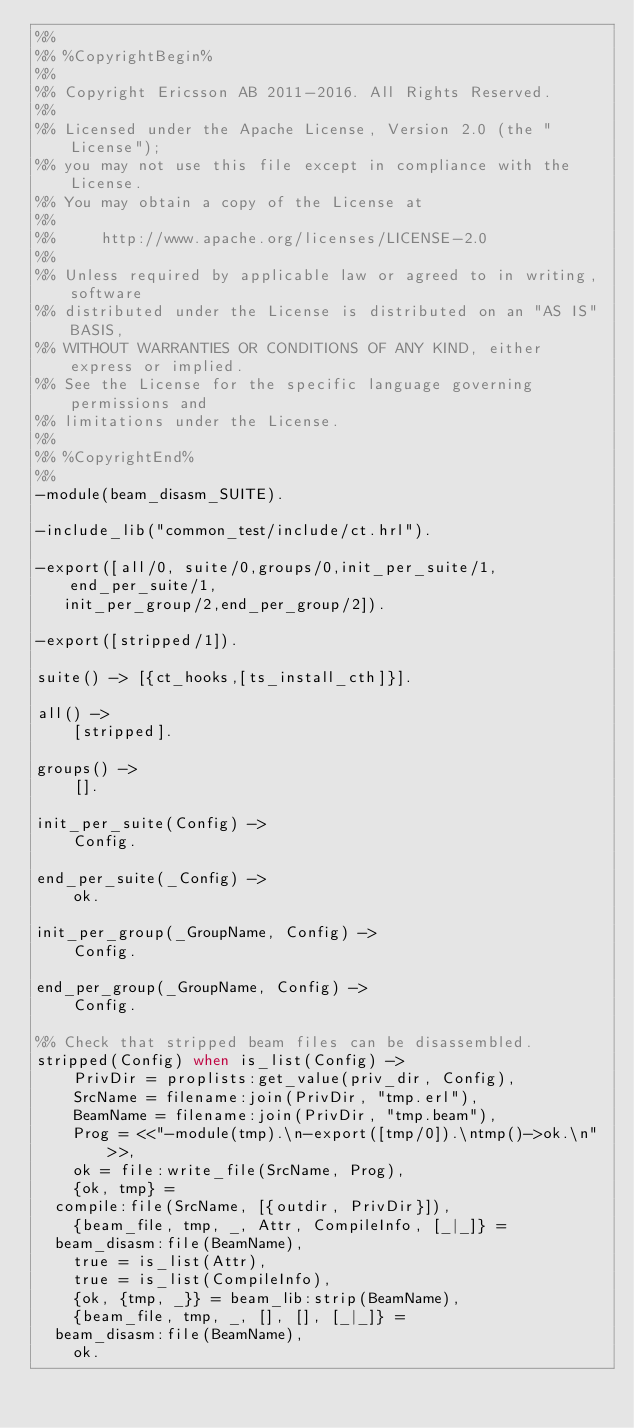<code> <loc_0><loc_0><loc_500><loc_500><_Erlang_>%%
%% %CopyrightBegin%
%%
%% Copyright Ericsson AB 2011-2016. All Rights Reserved.
%%
%% Licensed under the Apache License, Version 2.0 (the "License");
%% you may not use this file except in compliance with the License.
%% You may obtain a copy of the License at
%%
%%     http://www.apache.org/licenses/LICENSE-2.0
%%
%% Unless required by applicable law or agreed to in writing, software
%% distributed under the License is distributed on an "AS IS" BASIS,
%% WITHOUT WARRANTIES OR CONDITIONS OF ANY KIND, either express or implied.
%% See the License for the specific language governing permissions and
%% limitations under the License.
%%
%% %CopyrightEnd%
%%
-module(beam_disasm_SUITE).

-include_lib("common_test/include/ct.hrl").

-export([all/0, suite/0,groups/0,init_per_suite/1, end_per_suite/1,
	 init_per_group/2,end_per_group/2]).

-export([stripped/1]).

suite() -> [{ct_hooks,[ts_install_cth]}].

all() ->
    [stripped].

groups() ->
    [].

init_per_suite(Config) ->
    Config.

end_per_suite(_Config) ->
    ok.

init_per_group(_GroupName, Config) ->
    Config.

end_per_group(_GroupName, Config) ->
    Config.

%% Check that stripped beam files can be disassembled.
stripped(Config) when is_list(Config) ->
    PrivDir = proplists:get_value(priv_dir, Config),
    SrcName = filename:join(PrivDir, "tmp.erl"),
    BeamName = filename:join(PrivDir, "tmp.beam"),
    Prog = <<"-module(tmp).\n-export([tmp/0]).\ntmp()->ok.\n">>,
    ok = file:write_file(SrcName, Prog),
    {ok, tmp} =
	compile:file(SrcName, [{outdir, PrivDir}]),
    {beam_file, tmp, _, Attr, CompileInfo, [_|_]} =
	beam_disasm:file(BeamName),
    true = is_list(Attr),
    true = is_list(CompileInfo),
    {ok, {tmp, _}} = beam_lib:strip(BeamName),
    {beam_file, tmp, _, [], [], [_|_]} =
	beam_disasm:file(BeamName),
    ok.
</code> 